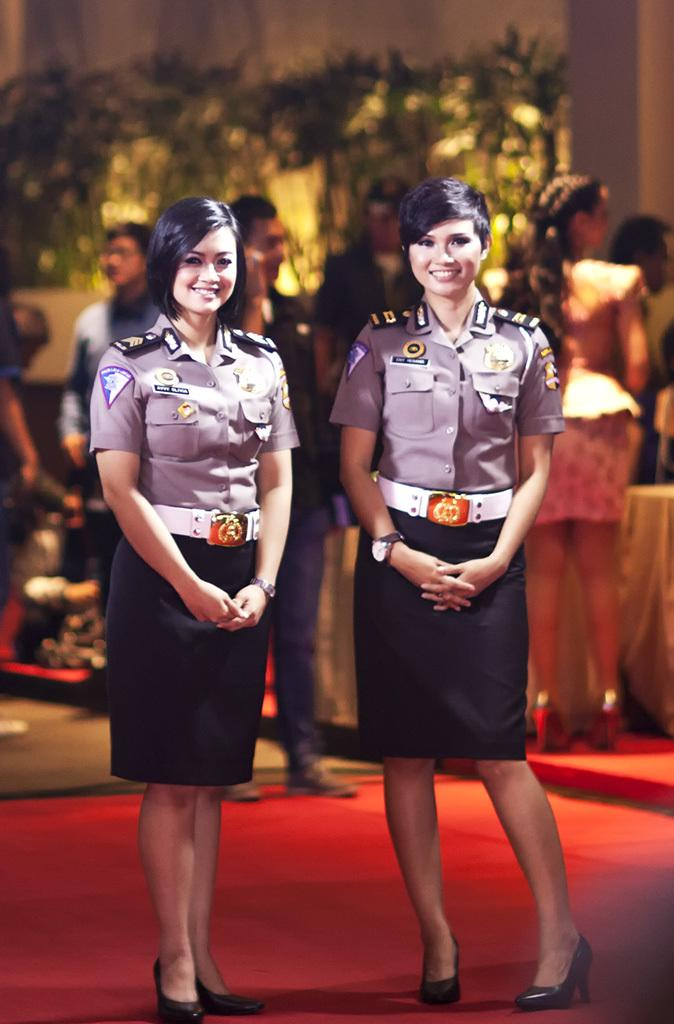How many women are in the image? There are two women standing in the image. What is the facial expression of the women? The women are smiling. Can you describe the background of the image? The background of the image is blurry. What can be seen in the background of the image? There are people, a table, and a wall visible in the background. What type of pizzas are being served on the table in the image? There is no table or pizzas present in the image; it features two women standing and smiling. What color is the sky in the image? There is no sky visible in the image; the background is blurry and consists of people, a table, and a wall. 